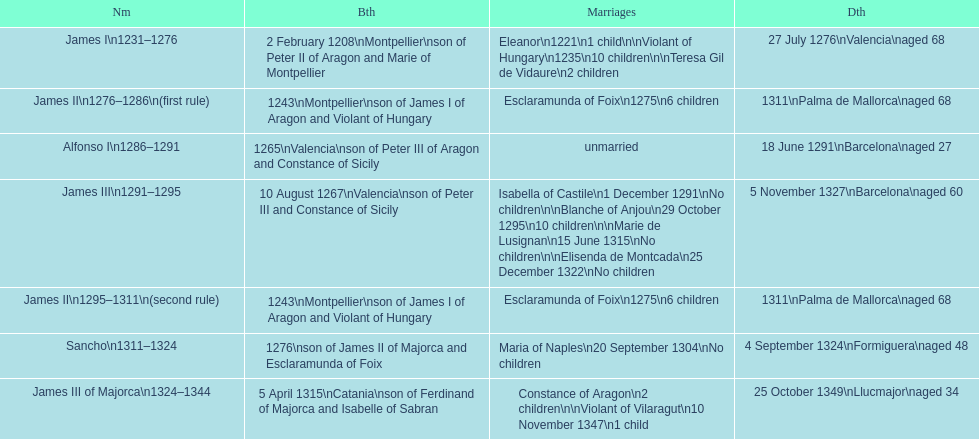Was james iii or sancho born in the year 1276? Sancho. 